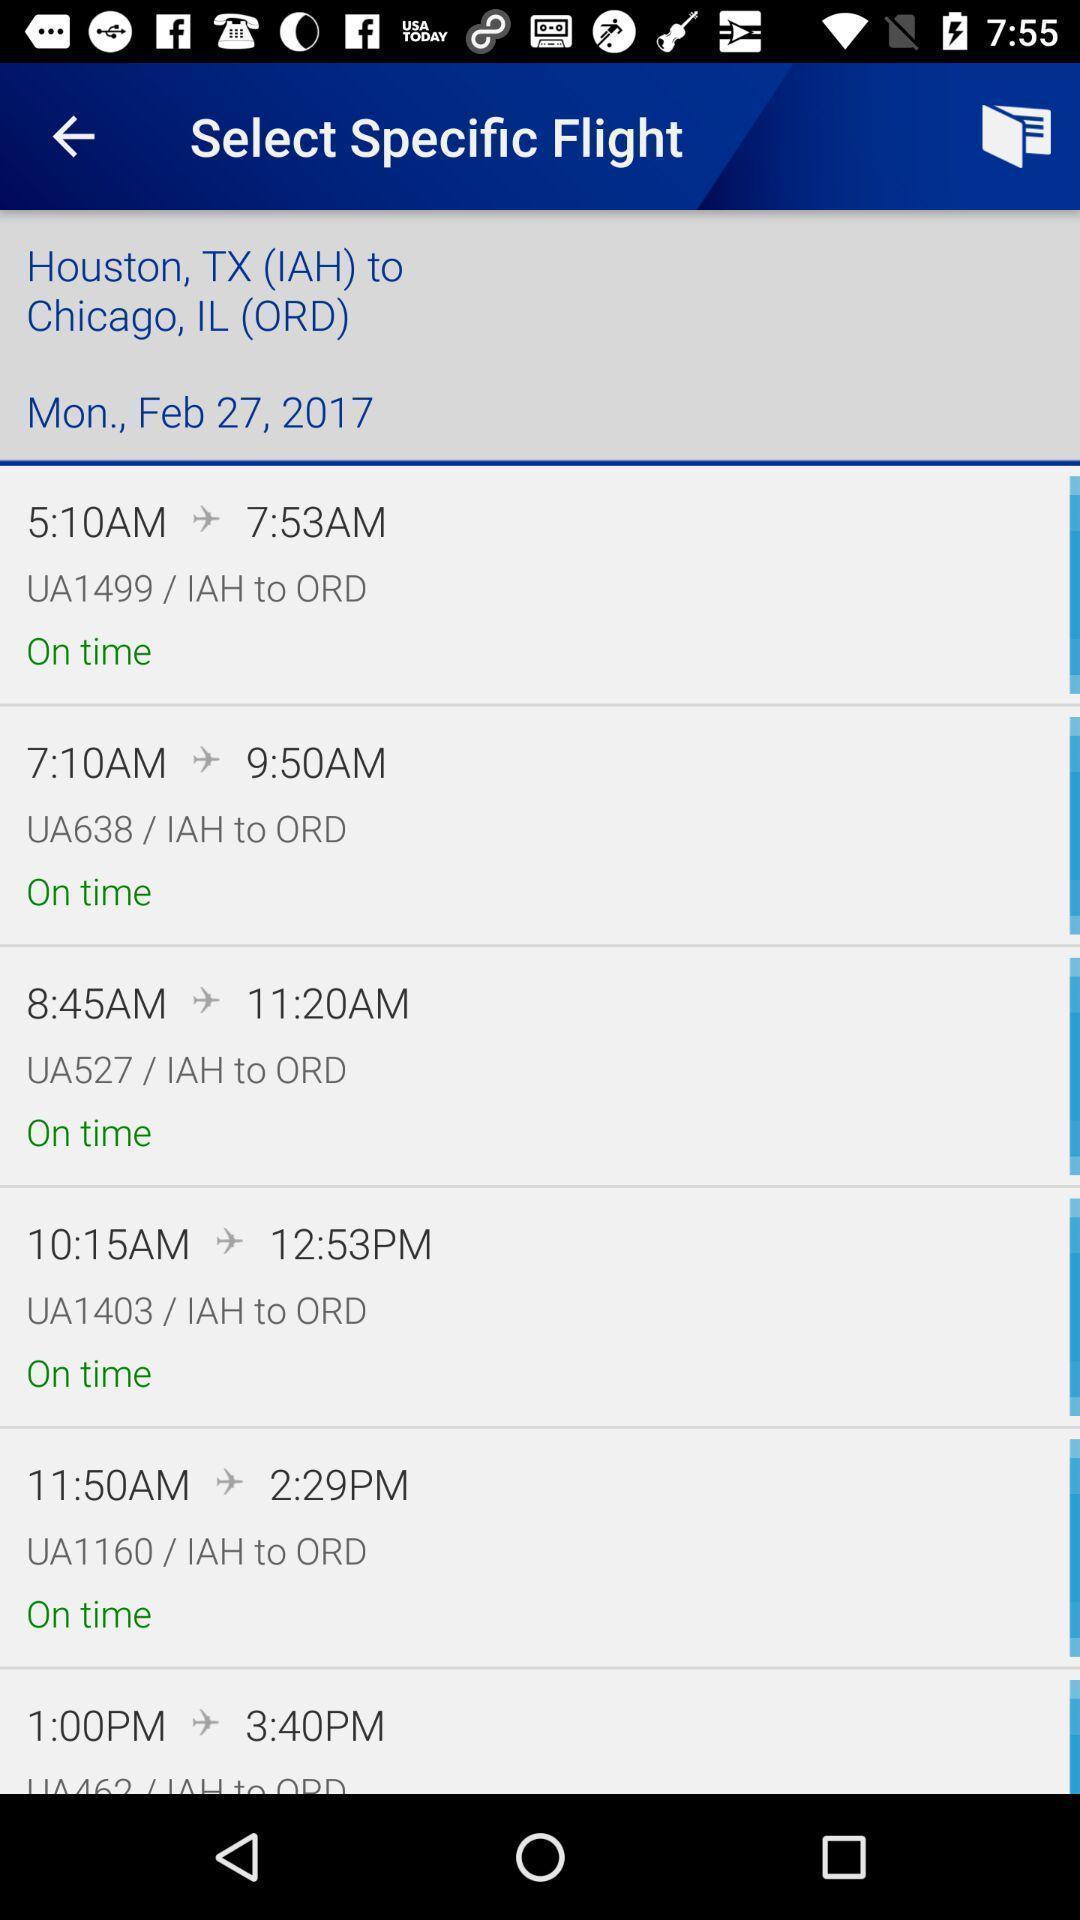Describe the content in this image. Screen page displaying various flight details in booking application. 